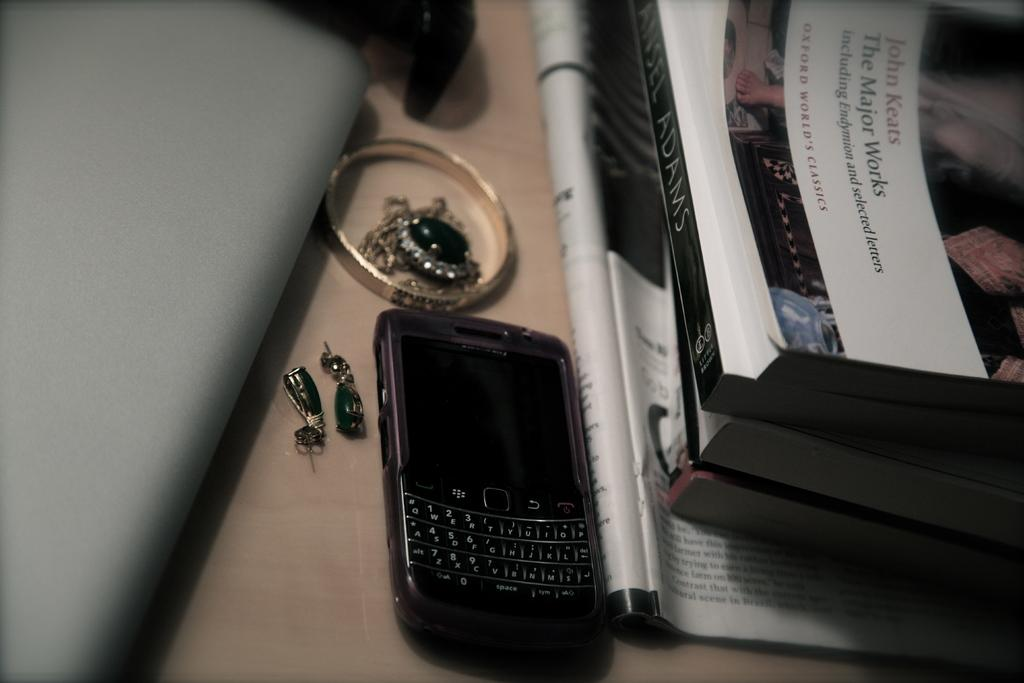Provide a one-sentence caption for the provided image. A phone and jewelry sit on a desk next to a few books, one called The Major Works by John Keats. 